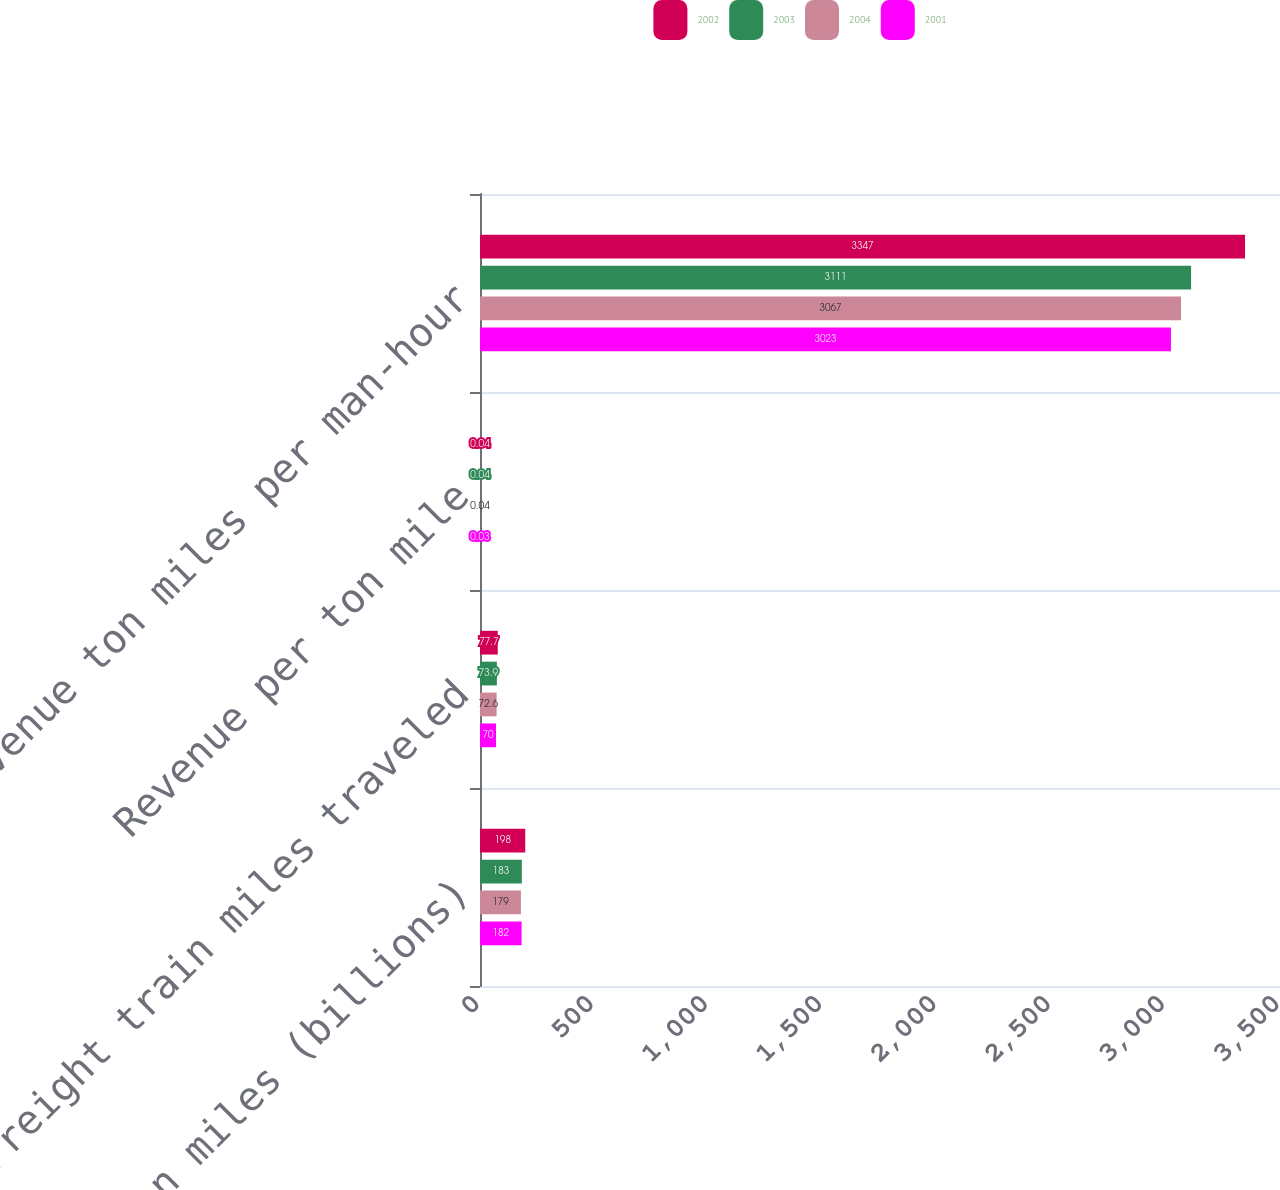<chart> <loc_0><loc_0><loc_500><loc_500><stacked_bar_chart><ecel><fcel>Revenue ton miles (billions)<fcel>Freight train miles traveled<fcel>Revenue per ton mile<fcel>Revenue ton miles per man-hour<nl><fcel>2002<fcel>198<fcel>77.7<fcel>0.04<fcel>3347<nl><fcel>2003<fcel>183<fcel>73.9<fcel>0.04<fcel>3111<nl><fcel>2004<fcel>179<fcel>72.6<fcel>0.04<fcel>3067<nl><fcel>2001<fcel>182<fcel>70<fcel>0.03<fcel>3023<nl></chart> 